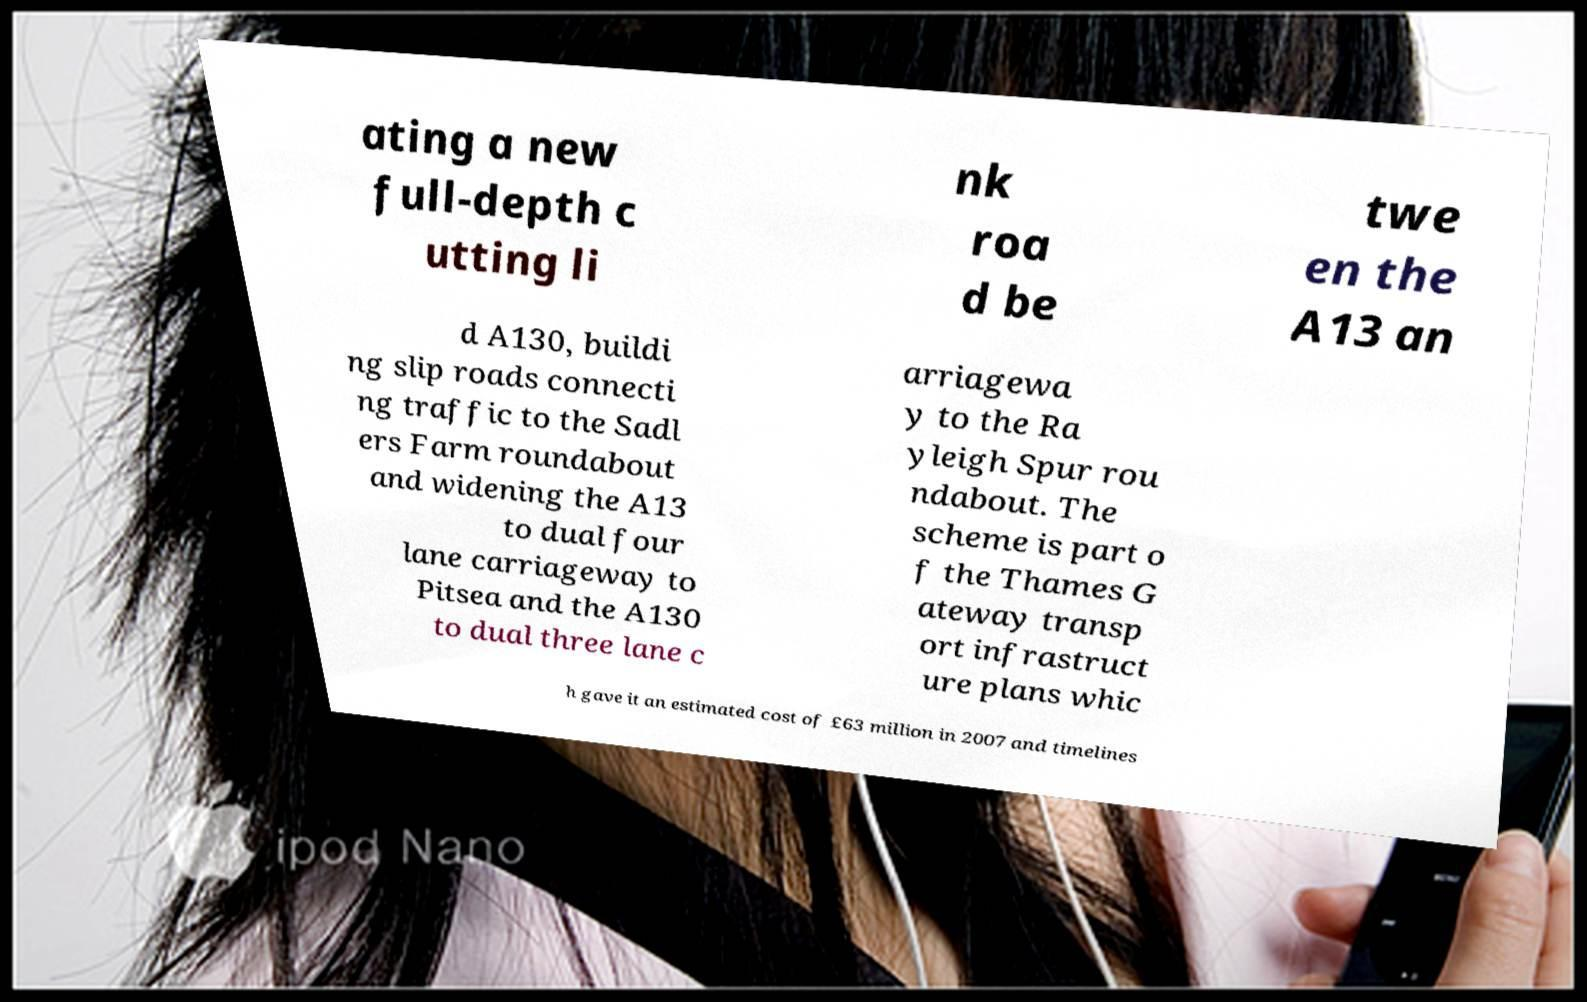For documentation purposes, I need the text within this image transcribed. Could you provide that? ating a new full-depth c utting li nk roa d be twe en the A13 an d A130, buildi ng slip roads connecti ng traffic to the Sadl ers Farm roundabout and widening the A13 to dual four lane carriageway to Pitsea and the A130 to dual three lane c arriagewa y to the Ra yleigh Spur rou ndabout. The scheme is part o f the Thames G ateway transp ort infrastruct ure plans whic h gave it an estimated cost of £63 million in 2007 and timelines 